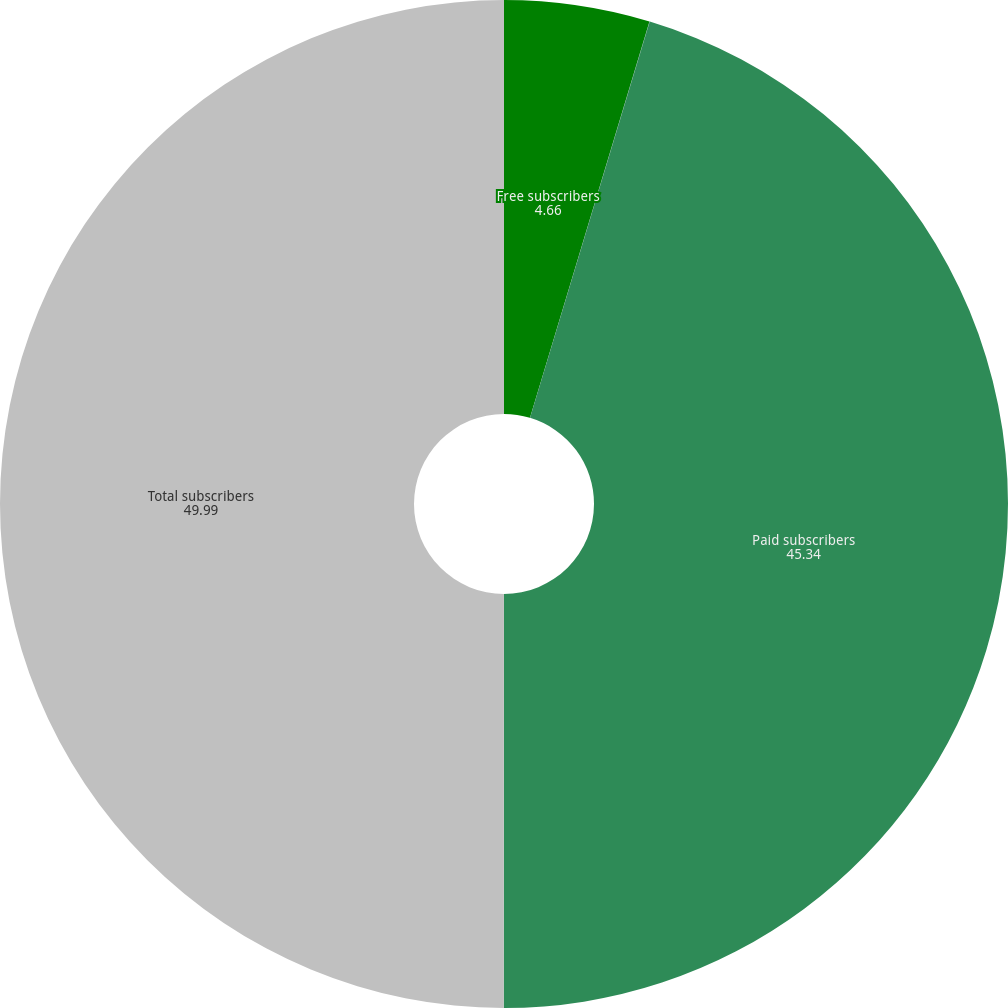Convert chart to OTSL. <chart><loc_0><loc_0><loc_500><loc_500><pie_chart><fcel>Free subscribers<fcel>As a percentage of total<fcel>Paid subscribers<fcel>Total subscribers<nl><fcel>4.66%<fcel>0.01%<fcel>45.34%<fcel>49.99%<nl></chart> 